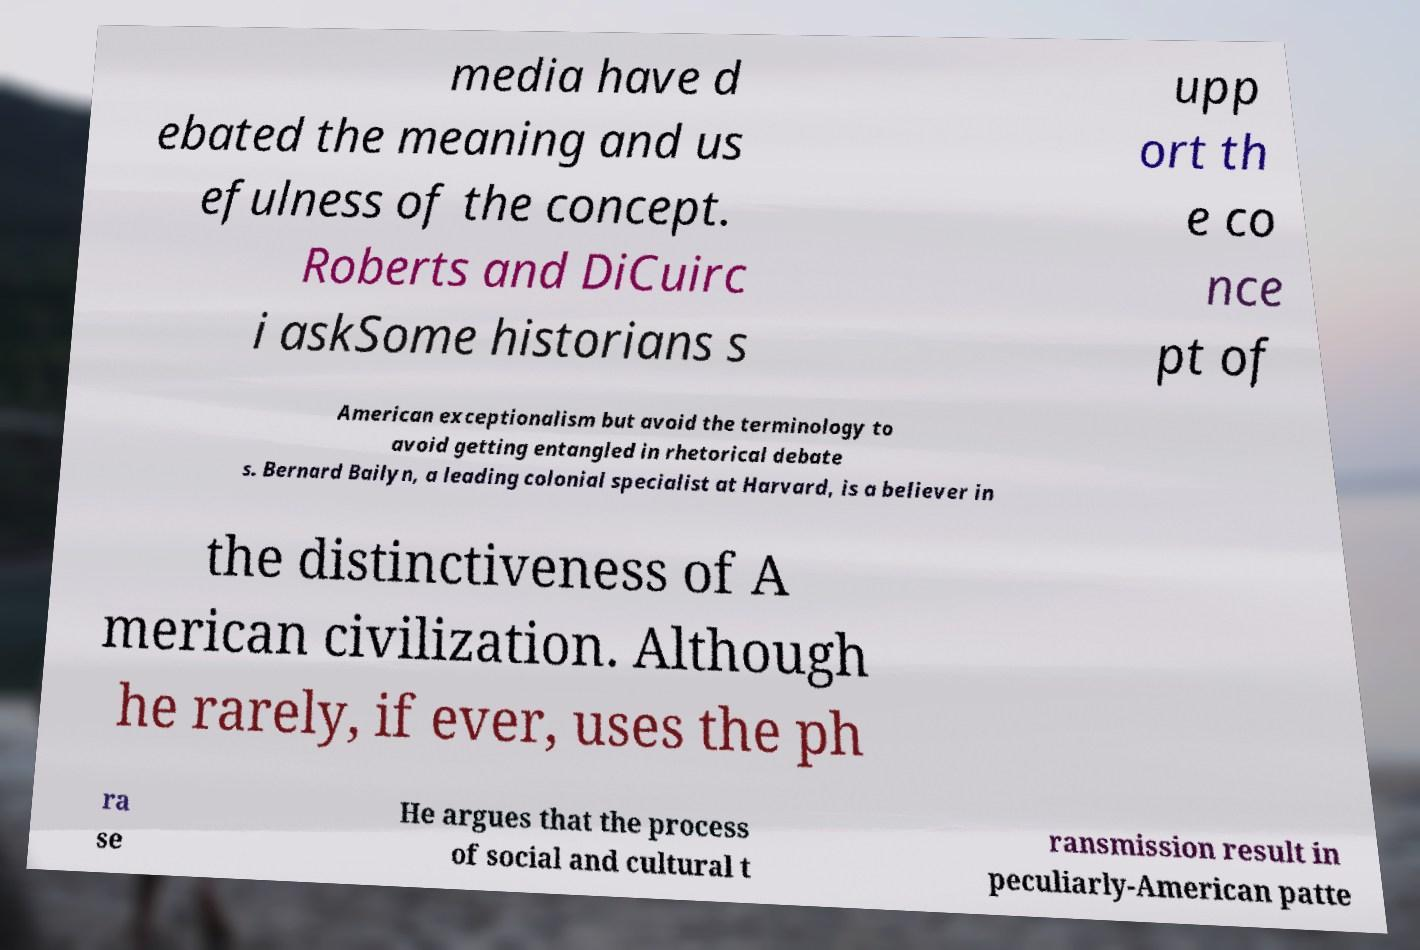For documentation purposes, I need the text within this image transcribed. Could you provide that? media have d ebated the meaning and us efulness of the concept. Roberts and DiCuirc i askSome historians s upp ort th e co nce pt of American exceptionalism but avoid the terminology to avoid getting entangled in rhetorical debate s. Bernard Bailyn, a leading colonial specialist at Harvard, is a believer in the distinctiveness of A merican civilization. Although he rarely, if ever, uses the ph ra se He argues that the process of social and cultural t ransmission result in peculiarly-American patte 